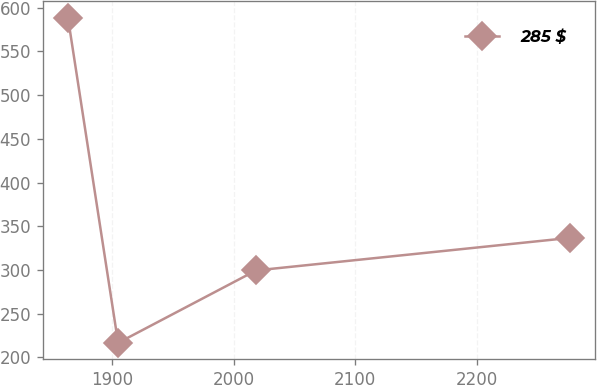Convert chart to OTSL. <chart><loc_0><loc_0><loc_500><loc_500><line_chart><ecel><fcel>285 $<nl><fcel>1864.04<fcel>588.5<nl><fcel>1905.24<fcel>216.72<nl><fcel>2018.48<fcel>299.55<nl><fcel>2276<fcel>336.73<nl></chart> 